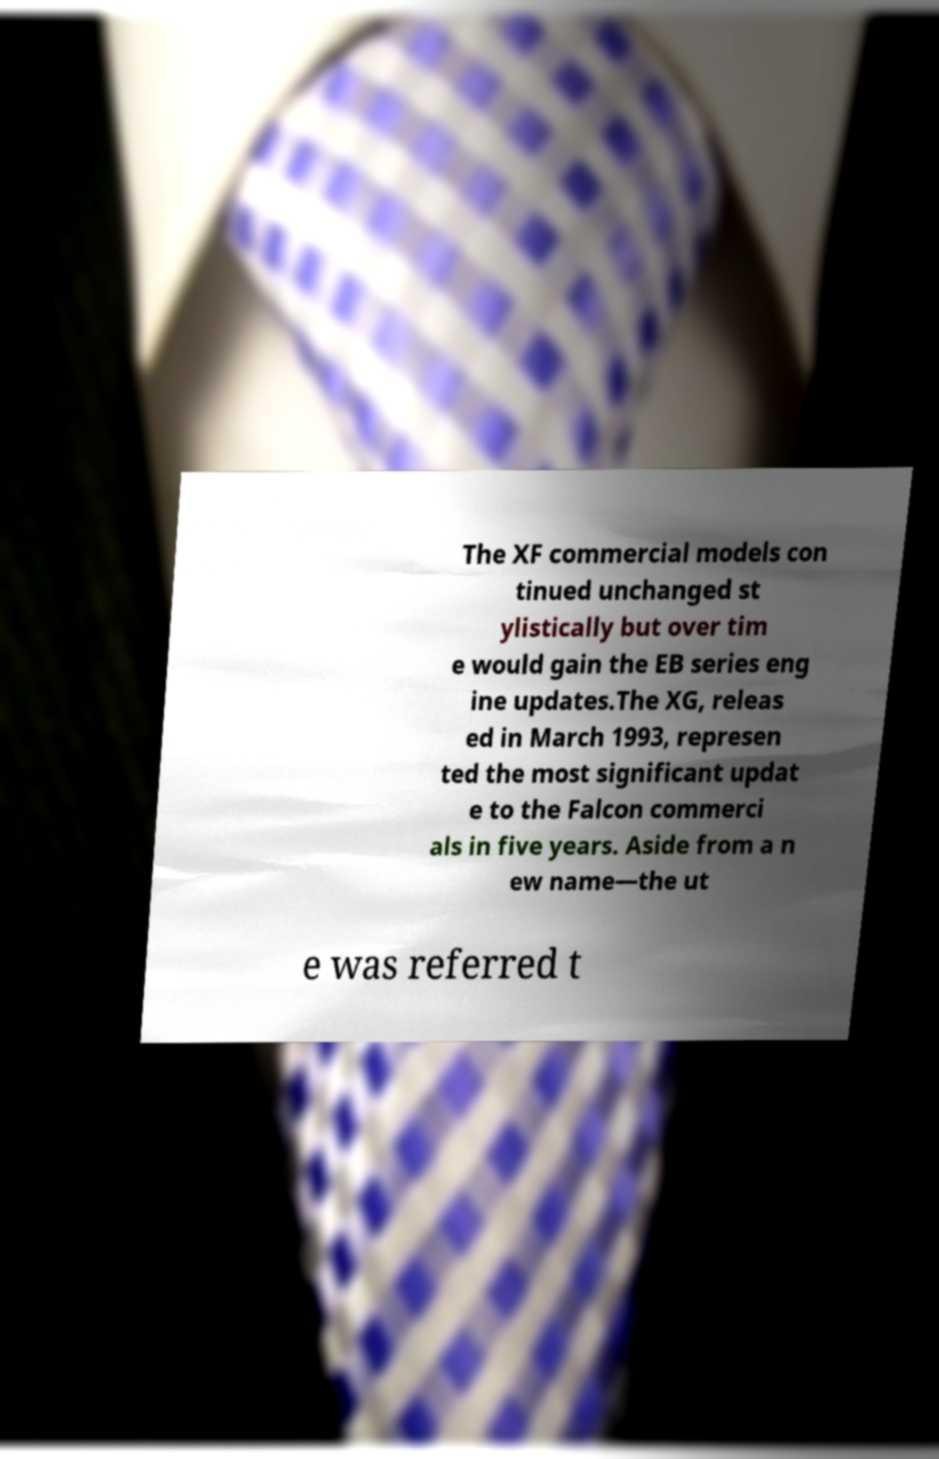Could you assist in decoding the text presented in this image and type it out clearly? The XF commercial models con tinued unchanged st ylistically but over tim e would gain the EB series eng ine updates.The XG, releas ed in March 1993, represen ted the most significant updat e to the Falcon commerci als in five years. Aside from a n ew name—the ut e was referred t 